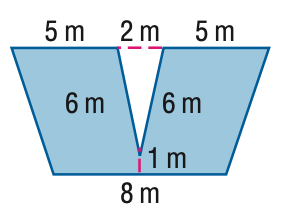Question: Find the area of the figure. Round to the nearest tenth if necessary.
Choices:
A. 5.9
B. 57.3
C. 63.2
D. 69.1
Answer with the letter. Answer: C 